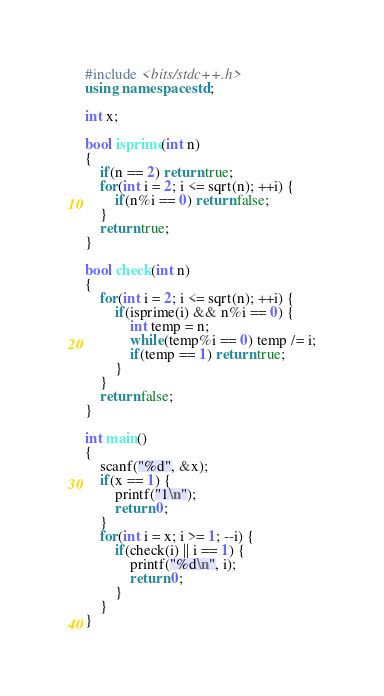Convert code to text. <code><loc_0><loc_0><loc_500><loc_500><_C++_>#include <bits/stdc++.h>
using namespace std;

int x;

bool isprime(int n)
{
    if(n == 2) return true;
    for(int i = 2; i <= sqrt(n); ++i) {
        if(n%i == 0) return false;
    }
    return true;
}

bool check(int n)
{
    for(int i = 2; i <= sqrt(n); ++i) {
        if(isprime(i) && n%i == 0) {
            int temp = n;
            while(temp%i == 0) temp /= i;
            if(temp == 1) return true;
        }
    }
    return false;
}

int main()
{
    scanf("%d", &x);
    if(x == 1) {
        printf("1\n");
        return 0;
    }
    for(int i = x; i >= 1; --i) {
        if(check(i) || i == 1) {
            printf("%d\n", i);
            return 0;
        }
    }
}</code> 